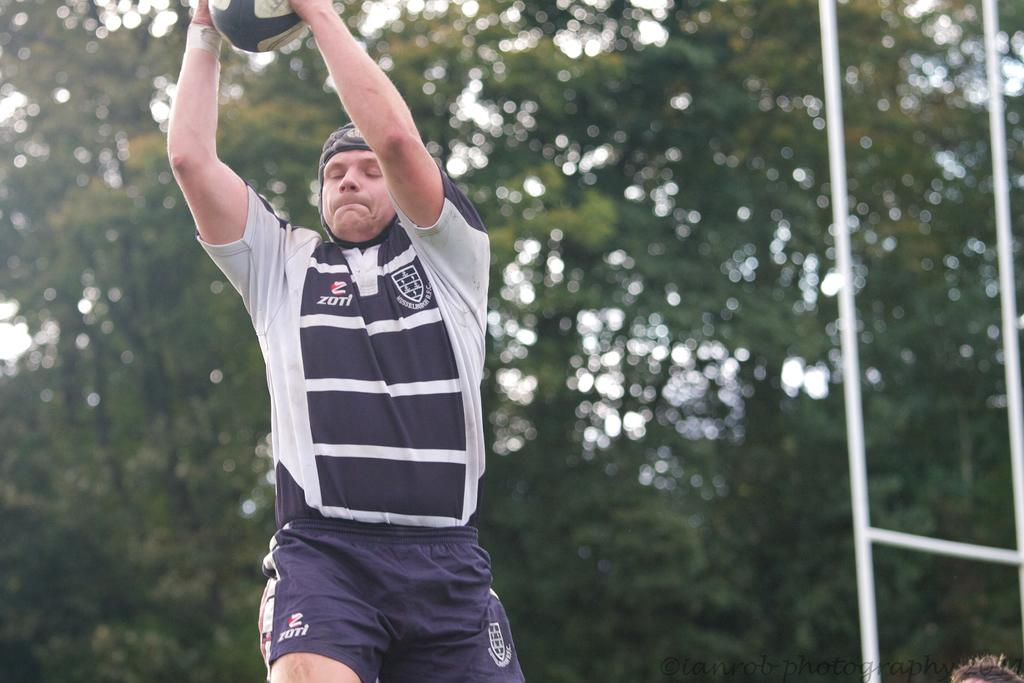<image>
Relay a brief, clear account of the picture shown. A man in a black and white shirt that says Zotl catches a rugby ball. 